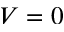<formula> <loc_0><loc_0><loc_500><loc_500>V = 0</formula> 